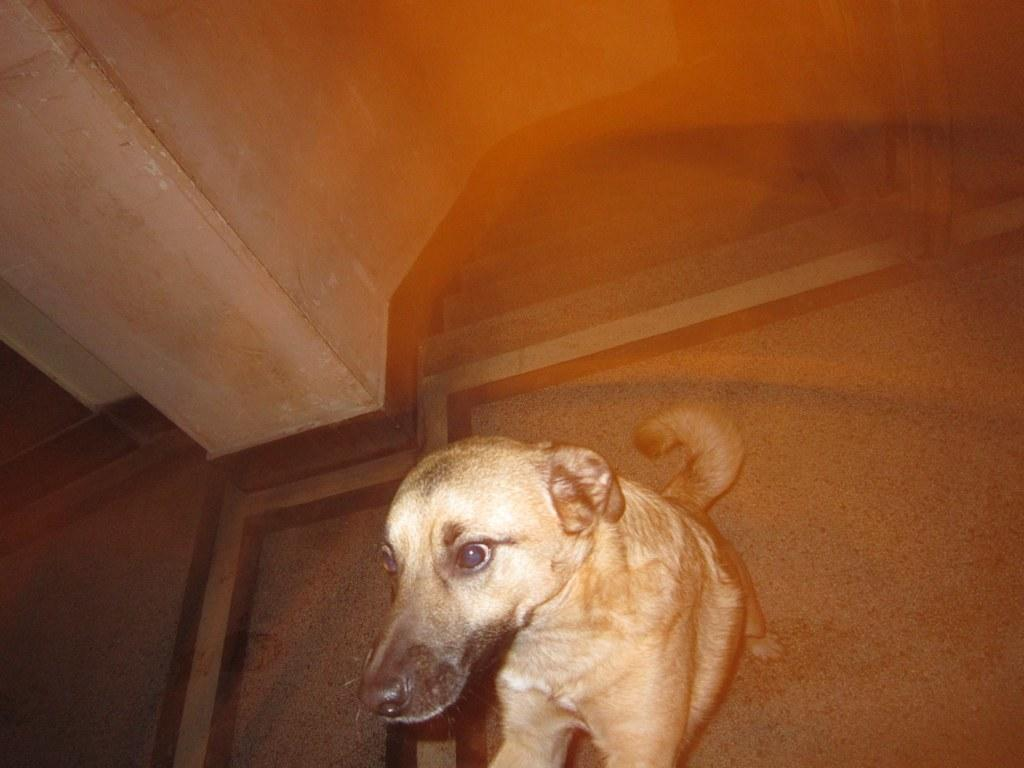What animal is sitting on the floor in the image? There is a dog sitting on the floor in the image. What architectural feature can be seen in the image? There are stairs visible in the image. What type of structure is present in the image? There is a wall in the image. What type of brass instrument is being played by the crowd in the image? There is no crowd or brass instrument present in the image; it only features a dog sitting on the floor, stairs, and a wall. 